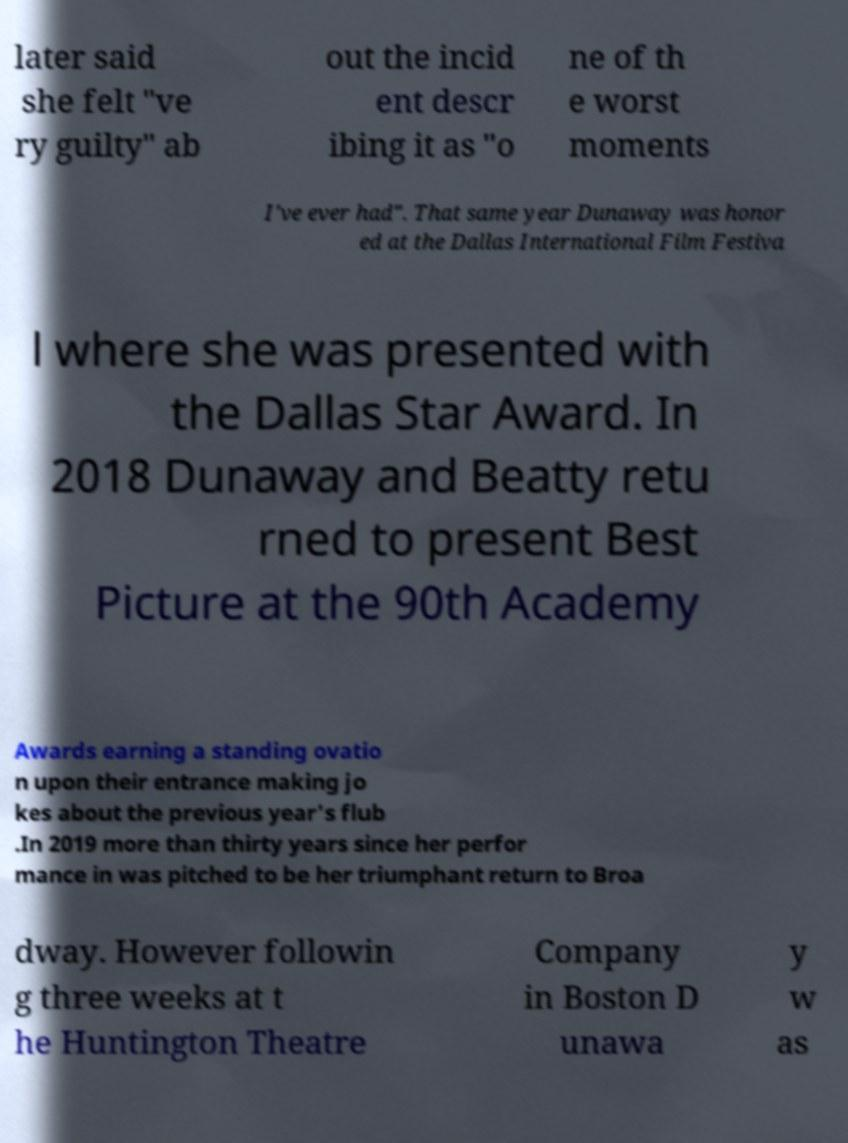Could you extract and type out the text from this image? later said she felt "ve ry guilty" ab out the incid ent descr ibing it as "o ne of th e worst moments I've ever had". That same year Dunaway was honor ed at the Dallas International Film Festiva l where she was presented with the Dallas Star Award. In 2018 Dunaway and Beatty retu rned to present Best Picture at the 90th Academy Awards earning a standing ovatio n upon their entrance making jo kes about the previous year's flub .In 2019 more than thirty years since her perfor mance in was pitched to be her triumphant return to Broa dway. However followin g three weeks at t he Huntington Theatre Company in Boston D unawa y w as 